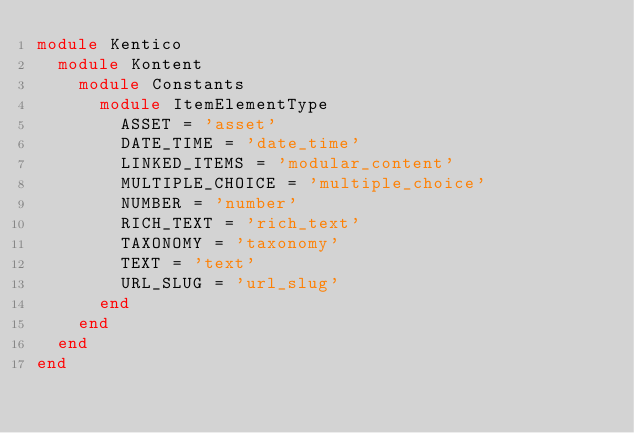Convert code to text. <code><loc_0><loc_0><loc_500><loc_500><_Ruby_>module Kentico
  module Kontent
    module Constants
      module ItemElementType
        ASSET = 'asset'
        DATE_TIME = 'date_time'
        LINKED_ITEMS = 'modular_content'
        MULTIPLE_CHOICE = 'multiple_choice'
        NUMBER = 'number'
        RICH_TEXT = 'rich_text'
        TAXONOMY = 'taxonomy'
        TEXT = 'text'
        URL_SLUG = 'url_slug'
      end
    end
  end
end
</code> 